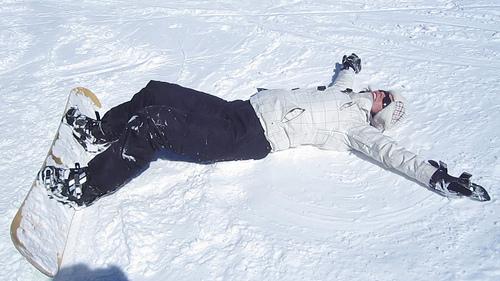Where is the snowboard?
Short answer required. On feet. What is he making?
Keep it brief. Snow angel. Why is the person lying on the ground?
Be succinct. Tired. Are they snowboarding?
Give a very brief answer. Yes. 